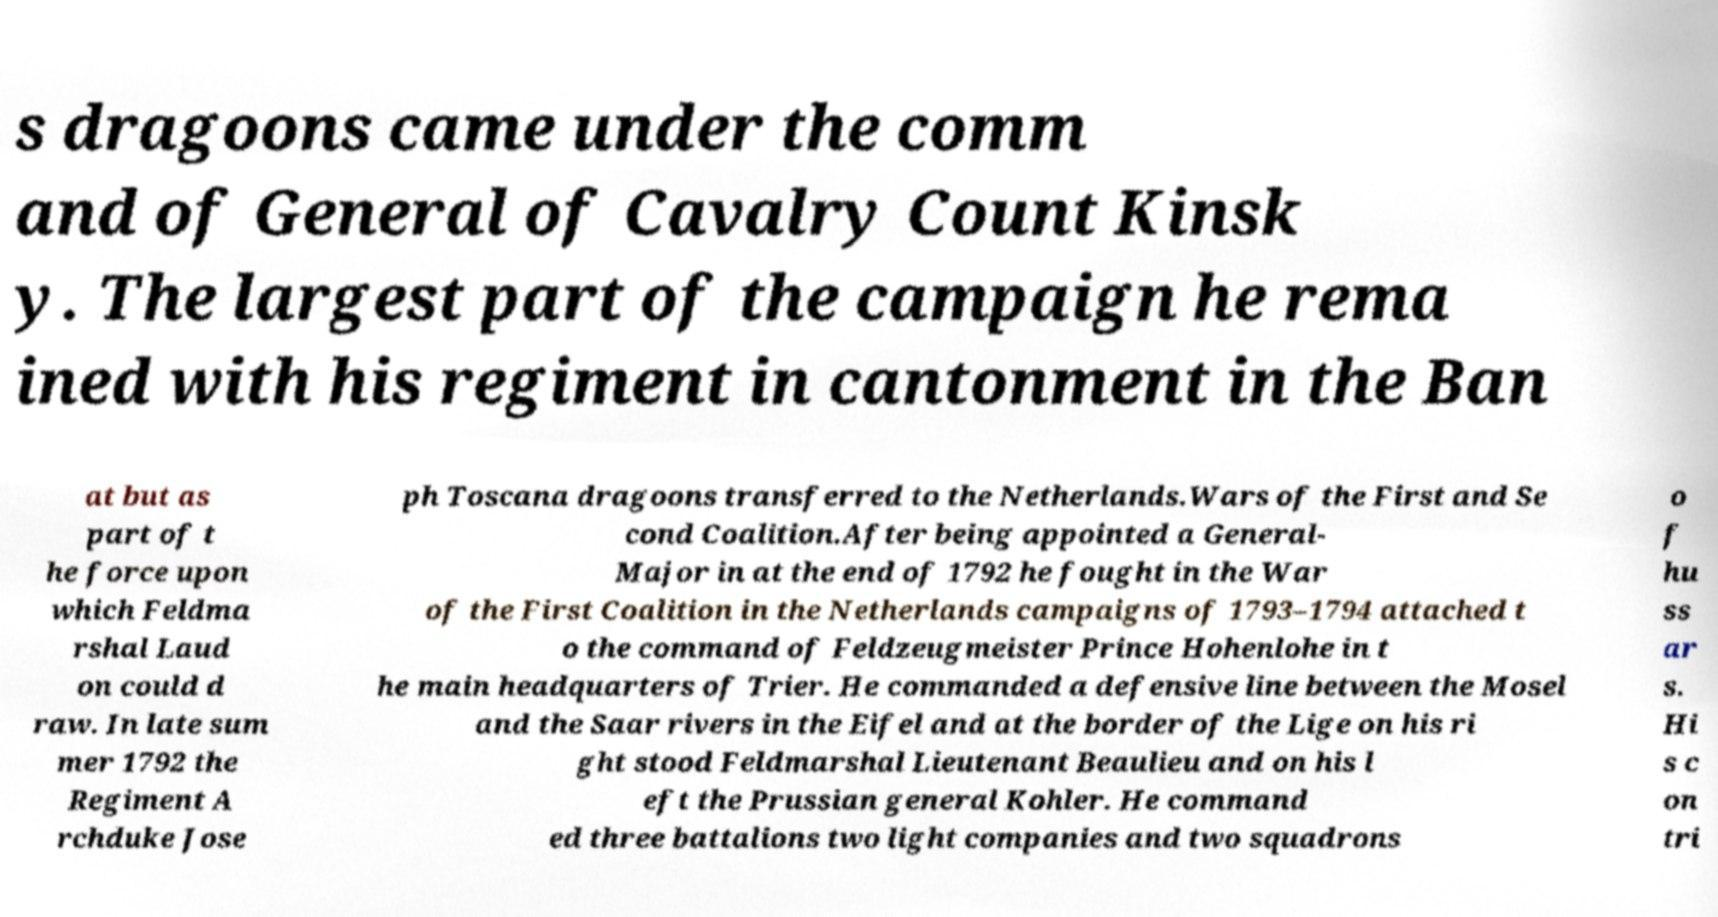Could you extract and type out the text from this image? s dragoons came under the comm and of General of Cavalry Count Kinsk y. The largest part of the campaign he rema ined with his regiment in cantonment in the Ban at but as part of t he force upon which Feldma rshal Laud on could d raw. In late sum mer 1792 the Regiment A rchduke Jose ph Toscana dragoons transferred to the Netherlands.Wars of the First and Se cond Coalition.After being appointed a General- Major in at the end of 1792 he fought in the War of the First Coalition in the Netherlands campaigns of 1793–1794 attached t o the command of Feldzeugmeister Prince Hohenlohe in t he main headquarters of Trier. He commanded a defensive line between the Mosel and the Saar rivers in the Eifel and at the border of the Lige on his ri ght stood Feldmarshal Lieutenant Beaulieu and on his l eft the Prussian general Kohler. He command ed three battalions two light companies and two squadrons o f hu ss ar s. Hi s c on tri 